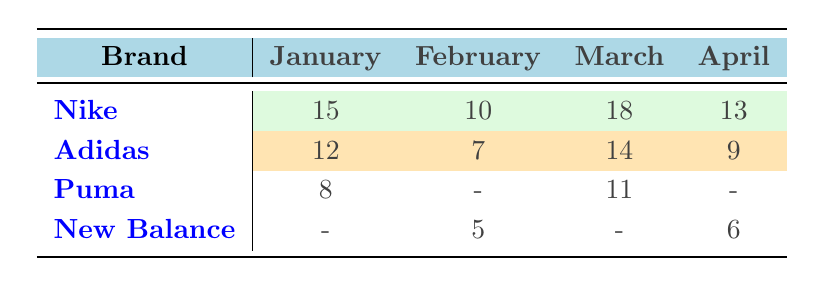What is the total number of Nike boots sold across all months? To find the total sales for Nike, we look at the numbers for each month: January (15), February (10), March (18), and April (13). We add these together: 15 + 10 + 18 + 13 = 56.
Answer: 56 Which brand sold the most boots in March? In March, Nike sold 18, Adidas sold 14, Puma sold 11, and New Balance sold none. The highest number is 18, which corresponds to Nike.
Answer: Nike How many boots did Adidas sell in total? We sum the Adidas sales across all months: January (12), February (7), March (14), and April (9). The total is 12 + 7 + 14 + 9 = 42.
Answer: 42 Did Puma have any sales in February? From the table, Puma's sales in February are shown as a dash (-), indicating zero sales. Thus, the answer is no.
Answer: No What is the average number of boots sold by New Balance? New Balance sold boots in February (5) and April (6). To find the average, we first calculate the total sales: 5 + 6 = 11. There are 2 months of sales. We divide the total by the count: 11 / 2 = 5.5.
Answer: 5.5 Which brand had the least total sales across the four months? Calculating total sales: Nike (56), Adidas (42), Puma (19), New Balance (11). The least total comes from New Balance with 11 sales.
Answer: New Balance What is the sales difference between Nike in March and Adidas in March? Nike sold 18 in March and Adidas sold 14. We find the difference: 18 - 14 = 4.
Answer: 4 Was there a month when no Puma boots were sold? According to the table, Puma has sales listed for March and January, but no sales in February and April. Therefore, yes, there were months with zero sales.
Answer: Yes 